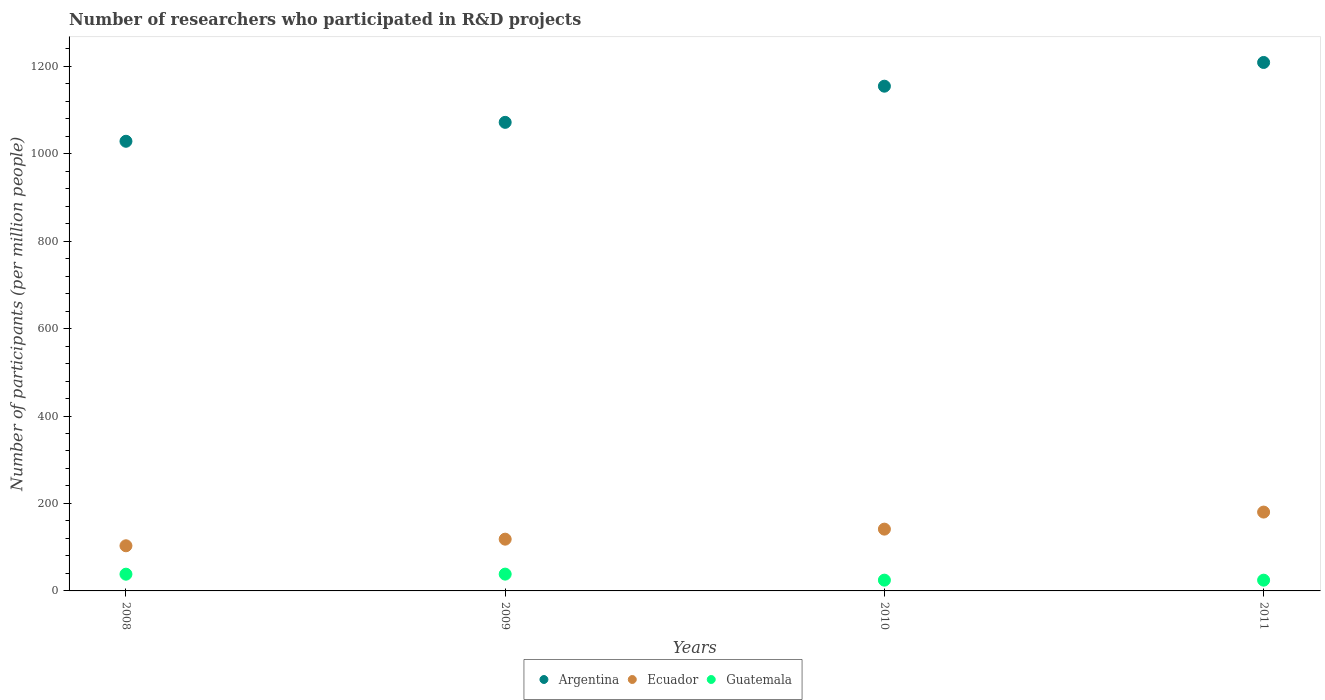How many different coloured dotlines are there?
Ensure brevity in your answer.  3. Is the number of dotlines equal to the number of legend labels?
Ensure brevity in your answer.  Yes. What is the number of researchers who participated in R&D projects in Ecuador in 2008?
Make the answer very short. 103.23. Across all years, what is the maximum number of researchers who participated in R&D projects in Argentina?
Ensure brevity in your answer.  1208.48. Across all years, what is the minimum number of researchers who participated in R&D projects in Ecuador?
Keep it short and to the point. 103.23. What is the total number of researchers who participated in R&D projects in Guatemala in the graph?
Your answer should be compact. 125.93. What is the difference between the number of researchers who participated in R&D projects in Guatemala in 2008 and that in 2011?
Your answer should be very brief. 13.69. What is the difference between the number of researchers who participated in R&D projects in Argentina in 2011 and the number of researchers who participated in R&D projects in Ecuador in 2009?
Make the answer very short. 1090.13. What is the average number of researchers who participated in R&D projects in Guatemala per year?
Offer a very short reply. 31.48. In the year 2010, what is the difference between the number of researchers who participated in R&D projects in Argentina and number of researchers who participated in R&D projects in Guatemala?
Keep it short and to the point. 1129.57. What is the ratio of the number of researchers who participated in R&D projects in Argentina in 2008 to that in 2010?
Offer a very short reply. 0.89. Is the number of researchers who participated in R&D projects in Ecuador in 2009 less than that in 2010?
Ensure brevity in your answer.  Yes. Is the difference between the number of researchers who participated in R&D projects in Argentina in 2009 and 2010 greater than the difference between the number of researchers who participated in R&D projects in Guatemala in 2009 and 2010?
Ensure brevity in your answer.  No. What is the difference between the highest and the second highest number of researchers who participated in R&D projects in Argentina?
Offer a terse response. 54.26. What is the difference between the highest and the lowest number of researchers who participated in R&D projects in Argentina?
Offer a terse response. 180.22. Does the number of researchers who participated in R&D projects in Guatemala monotonically increase over the years?
Your response must be concise. No. Is the number of researchers who participated in R&D projects in Argentina strictly greater than the number of researchers who participated in R&D projects in Ecuador over the years?
Keep it short and to the point. Yes. How many years are there in the graph?
Keep it short and to the point. 4. What is the difference between two consecutive major ticks on the Y-axis?
Make the answer very short. 200. How many legend labels are there?
Offer a very short reply. 3. What is the title of the graph?
Ensure brevity in your answer.  Number of researchers who participated in R&D projects. What is the label or title of the X-axis?
Offer a terse response. Years. What is the label or title of the Y-axis?
Offer a very short reply. Number of participants (per million people). What is the Number of participants (per million people) of Argentina in 2008?
Your answer should be very brief. 1028.26. What is the Number of participants (per million people) in Ecuador in 2008?
Provide a succinct answer. 103.23. What is the Number of participants (per million people) in Guatemala in 2008?
Make the answer very short. 38.28. What is the Number of participants (per million people) of Argentina in 2009?
Keep it short and to the point. 1071.53. What is the Number of participants (per million people) in Ecuador in 2009?
Provide a succinct answer. 118.35. What is the Number of participants (per million people) in Guatemala in 2009?
Your answer should be compact. 38.42. What is the Number of participants (per million people) in Argentina in 2010?
Offer a very short reply. 1154.21. What is the Number of participants (per million people) of Ecuador in 2010?
Ensure brevity in your answer.  141.3. What is the Number of participants (per million people) of Guatemala in 2010?
Offer a very short reply. 24.64. What is the Number of participants (per million people) of Argentina in 2011?
Keep it short and to the point. 1208.48. What is the Number of participants (per million people) in Ecuador in 2011?
Offer a terse response. 180.3. What is the Number of participants (per million people) in Guatemala in 2011?
Provide a short and direct response. 24.59. Across all years, what is the maximum Number of participants (per million people) of Argentina?
Offer a terse response. 1208.48. Across all years, what is the maximum Number of participants (per million people) of Ecuador?
Your answer should be very brief. 180.3. Across all years, what is the maximum Number of participants (per million people) in Guatemala?
Keep it short and to the point. 38.42. Across all years, what is the minimum Number of participants (per million people) in Argentina?
Offer a very short reply. 1028.26. Across all years, what is the minimum Number of participants (per million people) of Ecuador?
Your response must be concise. 103.23. Across all years, what is the minimum Number of participants (per million people) of Guatemala?
Offer a terse response. 24.59. What is the total Number of participants (per million people) of Argentina in the graph?
Offer a terse response. 4462.48. What is the total Number of participants (per million people) in Ecuador in the graph?
Ensure brevity in your answer.  543.18. What is the total Number of participants (per million people) of Guatemala in the graph?
Your response must be concise. 125.93. What is the difference between the Number of participants (per million people) of Argentina in 2008 and that in 2009?
Offer a terse response. -43.27. What is the difference between the Number of participants (per million people) in Ecuador in 2008 and that in 2009?
Offer a terse response. -15.12. What is the difference between the Number of participants (per million people) of Guatemala in 2008 and that in 2009?
Offer a terse response. -0.14. What is the difference between the Number of participants (per million people) of Argentina in 2008 and that in 2010?
Make the answer very short. -125.95. What is the difference between the Number of participants (per million people) in Ecuador in 2008 and that in 2010?
Your answer should be very brief. -38.07. What is the difference between the Number of participants (per million people) of Guatemala in 2008 and that in 2010?
Offer a very short reply. 13.64. What is the difference between the Number of participants (per million people) in Argentina in 2008 and that in 2011?
Your answer should be compact. -180.22. What is the difference between the Number of participants (per million people) of Ecuador in 2008 and that in 2011?
Offer a very short reply. -77.06. What is the difference between the Number of participants (per million people) in Guatemala in 2008 and that in 2011?
Ensure brevity in your answer.  13.69. What is the difference between the Number of participants (per million people) of Argentina in 2009 and that in 2010?
Ensure brevity in your answer.  -82.68. What is the difference between the Number of participants (per million people) in Ecuador in 2009 and that in 2010?
Keep it short and to the point. -22.95. What is the difference between the Number of participants (per million people) of Guatemala in 2009 and that in 2010?
Your response must be concise. 13.78. What is the difference between the Number of participants (per million people) in Argentina in 2009 and that in 2011?
Give a very brief answer. -136.95. What is the difference between the Number of participants (per million people) in Ecuador in 2009 and that in 2011?
Provide a short and direct response. -61.95. What is the difference between the Number of participants (per million people) in Guatemala in 2009 and that in 2011?
Provide a short and direct response. 13.84. What is the difference between the Number of participants (per million people) in Argentina in 2010 and that in 2011?
Provide a succinct answer. -54.26. What is the difference between the Number of participants (per million people) of Ecuador in 2010 and that in 2011?
Offer a very short reply. -39. What is the difference between the Number of participants (per million people) of Guatemala in 2010 and that in 2011?
Your answer should be very brief. 0.05. What is the difference between the Number of participants (per million people) of Argentina in 2008 and the Number of participants (per million people) of Ecuador in 2009?
Provide a succinct answer. 909.91. What is the difference between the Number of participants (per million people) in Argentina in 2008 and the Number of participants (per million people) in Guatemala in 2009?
Ensure brevity in your answer.  989.83. What is the difference between the Number of participants (per million people) in Ecuador in 2008 and the Number of participants (per million people) in Guatemala in 2009?
Your answer should be compact. 64.81. What is the difference between the Number of participants (per million people) of Argentina in 2008 and the Number of participants (per million people) of Ecuador in 2010?
Your answer should be compact. 886.96. What is the difference between the Number of participants (per million people) of Argentina in 2008 and the Number of participants (per million people) of Guatemala in 2010?
Keep it short and to the point. 1003.62. What is the difference between the Number of participants (per million people) of Ecuador in 2008 and the Number of participants (per million people) of Guatemala in 2010?
Provide a succinct answer. 78.59. What is the difference between the Number of participants (per million people) of Argentina in 2008 and the Number of participants (per million people) of Ecuador in 2011?
Ensure brevity in your answer.  847.96. What is the difference between the Number of participants (per million people) in Argentina in 2008 and the Number of participants (per million people) in Guatemala in 2011?
Provide a succinct answer. 1003.67. What is the difference between the Number of participants (per million people) of Ecuador in 2008 and the Number of participants (per million people) of Guatemala in 2011?
Provide a succinct answer. 78.65. What is the difference between the Number of participants (per million people) of Argentina in 2009 and the Number of participants (per million people) of Ecuador in 2010?
Your answer should be compact. 930.23. What is the difference between the Number of participants (per million people) in Argentina in 2009 and the Number of participants (per million people) in Guatemala in 2010?
Provide a short and direct response. 1046.89. What is the difference between the Number of participants (per million people) in Ecuador in 2009 and the Number of participants (per million people) in Guatemala in 2010?
Make the answer very short. 93.71. What is the difference between the Number of participants (per million people) in Argentina in 2009 and the Number of participants (per million people) in Ecuador in 2011?
Ensure brevity in your answer.  891.24. What is the difference between the Number of participants (per million people) of Argentina in 2009 and the Number of participants (per million people) of Guatemala in 2011?
Keep it short and to the point. 1046.94. What is the difference between the Number of participants (per million people) in Ecuador in 2009 and the Number of participants (per million people) in Guatemala in 2011?
Your answer should be very brief. 93.76. What is the difference between the Number of participants (per million people) of Argentina in 2010 and the Number of participants (per million people) of Ecuador in 2011?
Your response must be concise. 973.92. What is the difference between the Number of participants (per million people) of Argentina in 2010 and the Number of participants (per million people) of Guatemala in 2011?
Make the answer very short. 1129.63. What is the difference between the Number of participants (per million people) of Ecuador in 2010 and the Number of participants (per million people) of Guatemala in 2011?
Your answer should be very brief. 116.71. What is the average Number of participants (per million people) in Argentina per year?
Your answer should be compact. 1115.62. What is the average Number of participants (per million people) in Ecuador per year?
Offer a very short reply. 135.79. What is the average Number of participants (per million people) of Guatemala per year?
Your answer should be compact. 31.48. In the year 2008, what is the difference between the Number of participants (per million people) in Argentina and Number of participants (per million people) in Ecuador?
Your answer should be very brief. 925.03. In the year 2008, what is the difference between the Number of participants (per million people) of Argentina and Number of participants (per million people) of Guatemala?
Your answer should be compact. 989.98. In the year 2008, what is the difference between the Number of participants (per million people) of Ecuador and Number of participants (per million people) of Guatemala?
Your answer should be compact. 64.95. In the year 2009, what is the difference between the Number of participants (per million people) of Argentina and Number of participants (per million people) of Ecuador?
Offer a terse response. 953.18. In the year 2009, what is the difference between the Number of participants (per million people) of Argentina and Number of participants (per million people) of Guatemala?
Ensure brevity in your answer.  1033.11. In the year 2009, what is the difference between the Number of participants (per million people) in Ecuador and Number of participants (per million people) in Guatemala?
Give a very brief answer. 79.93. In the year 2010, what is the difference between the Number of participants (per million people) in Argentina and Number of participants (per million people) in Ecuador?
Offer a very short reply. 1012.91. In the year 2010, what is the difference between the Number of participants (per million people) in Argentina and Number of participants (per million people) in Guatemala?
Provide a succinct answer. 1129.57. In the year 2010, what is the difference between the Number of participants (per million people) of Ecuador and Number of participants (per million people) of Guatemala?
Provide a succinct answer. 116.66. In the year 2011, what is the difference between the Number of participants (per million people) in Argentina and Number of participants (per million people) in Ecuador?
Make the answer very short. 1028.18. In the year 2011, what is the difference between the Number of participants (per million people) in Argentina and Number of participants (per million people) in Guatemala?
Your response must be concise. 1183.89. In the year 2011, what is the difference between the Number of participants (per million people) in Ecuador and Number of participants (per million people) in Guatemala?
Give a very brief answer. 155.71. What is the ratio of the Number of participants (per million people) in Argentina in 2008 to that in 2009?
Keep it short and to the point. 0.96. What is the ratio of the Number of participants (per million people) of Ecuador in 2008 to that in 2009?
Give a very brief answer. 0.87. What is the ratio of the Number of participants (per million people) of Guatemala in 2008 to that in 2009?
Give a very brief answer. 1. What is the ratio of the Number of participants (per million people) in Argentina in 2008 to that in 2010?
Your answer should be compact. 0.89. What is the ratio of the Number of participants (per million people) in Ecuador in 2008 to that in 2010?
Your answer should be compact. 0.73. What is the ratio of the Number of participants (per million people) in Guatemala in 2008 to that in 2010?
Offer a very short reply. 1.55. What is the ratio of the Number of participants (per million people) in Argentina in 2008 to that in 2011?
Ensure brevity in your answer.  0.85. What is the ratio of the Number of participants (per million people) of Ecuador in 2008 to that in 2011?
Offer a very short reply. 0.57. What is the ratio of the Number of participants (per million people) of Guatemala in 2008 to that in 2011?
Give a very brief answer. 1.56. What is the ratio of the Number of participants (per million people) in Argentina in 2009 to that in 2010?
Your response must be concise. 0.93. What is the ratio of the Number of participants (per million people) in Ecuador in 2009 to that in 2010?
Offer a terse response. 0.84. What is the ratio of the Number of participants (per million people) of Guatemala in 2009 to that in 2010?
Provide a succinct answer. 1.56. What is the ratio of the Number of participants (per million people) of Argentina in 2009 to that in 2011?
Offer a very short reply. 0.89. What is the ratio of the Number of participants (per million people) in Ecuador in 2009 to that in 2011?
Provide a short and direct response. 0.66. What is the ratio of the Number of participants (per million people) in Guatemala in 2009 to that in 2011?
Ensure brevity in your answer.  1.56. What is the ratio of the Number of participants (per million people) of Argentina in 2010 to that in 2011?
Your response must be concise. 0.96. What is the ratio of the Number of participants (per million people) of Ecuador in 2010 to that in 2011?
Your response must be concise. 0.78. What is the ratio of the Number of participants (per million people) of Guatemala in 2010 to that in 2011?
Make the answer very short. 1. What is the difference between the highest and the second highest Number of participants (per million people) in Argentina?
Make the answer very short. 54.26. What is the difference between the highest and the second highest Number of participants (per million people) of Ecuador?
Give a very brief answer. 39. What is the difference between the highest and the second highest Number of participants (per million people) in Guatemala?
Keep it short and to the point. 0.14. What is the difference between the highest and the lowest Number of participants (per million people) of Argentina?
Provide a succinct answer. 180.22. What is the difference between the highest and the lowest Number of participants (per million people) of Ecuador?
Provide a short and direct response. 77.06. What is the difference between the highest and the lowest Number of participants (per million people) in Guatemala?
Make the answer very short. 13.84. 